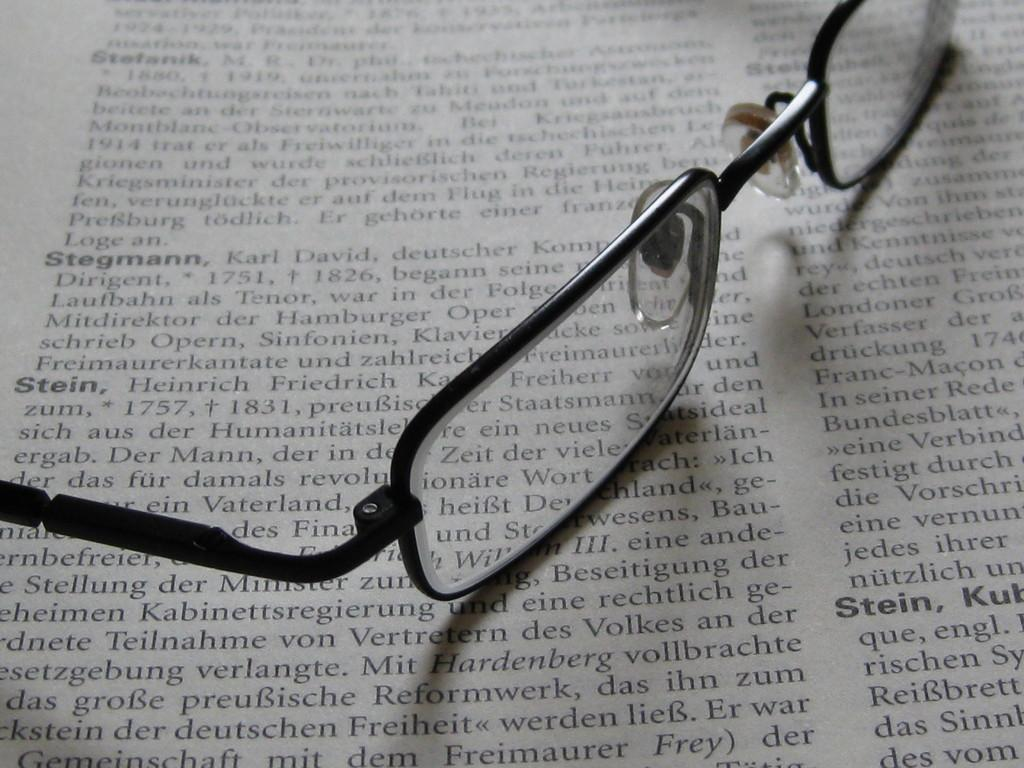What object is present in the image that is commonly used for vision correction? There are spectacles in the image. Where are the spectacles placed in the image? The spectacles are on a paper. What can be found on the paper besides the spectacles? There is writing on the paper. What type of bait is used by the team to achieve harmony in the image? There is no team, bait, or mention of harmony in the image; it only features spectacles on a paper with writing. 